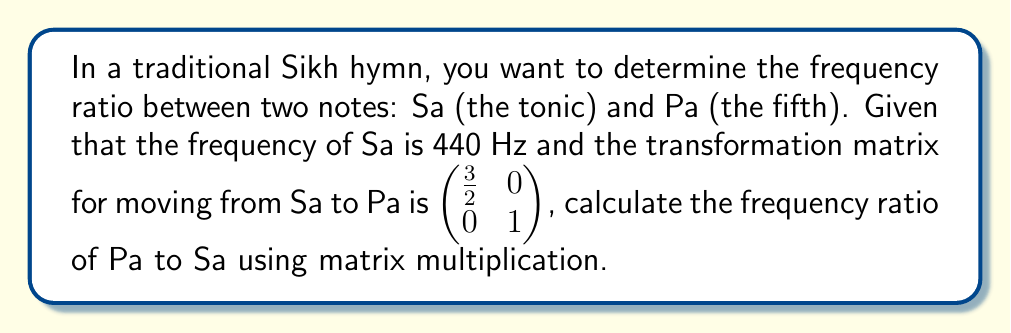Solve this math problem. 1) Let's represent the frequency of Sa as a column vector:
   $$\vec{Sa} = \begin{pmatrix} 440 \\ 1 \end{pmatrix}$$

2) The transformation matrix to move from Sa to Pa is given as:
   $$T = \begin{pmatrix} \frac{3}{2} & 0 \\ 0 & 1 \end{pmatrix}$$

3) To find the frequency of Pa, we multiply the transformation matrix by the Sa vector:
   $$\vec{Pa} = T \cdot \vec{Sa} = \begin{pmatrix} \frac{3}{2} & 0 \\ 0 & 1 \end{pmatrix} \cdot \begin{pmatrix} 440 \\ 1 \end{pmatrix}$$

4) Performing the matrix multiplication:
   $$\vec{Pa} = \begin{pmatrix} \frac{3}{2} \cdot 440 + 0 \cdot 1 \\ 0 \cdot 440 + 1 \cdot 1 \end{pmatrix} = \begin{pmatrix} 660 \\ 1 \end{pmatrix}$$

5) The frequency ratio of Pa to Sa is the ratio of their frequencies:
   $$\text{Ratio} = \frac{660}{440} = \frac{3}{2}$$

This ratio of 3:2 is the perfect fifth in music theory, which corresponds to the relationship between Sa and Pa in the Indian musical scale.
Answer: $\frac{3}{2}$ 